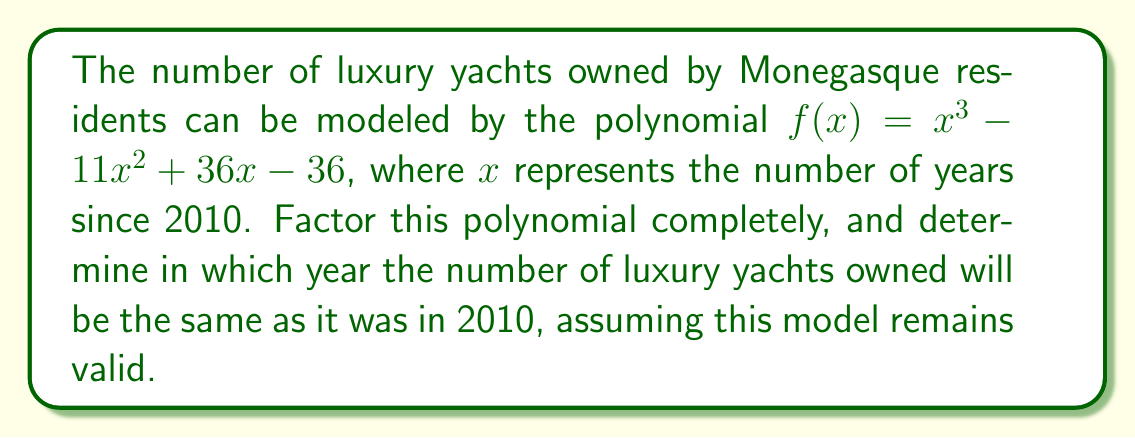Teach me how to tackle this problem. Let's approach this step-by-step:

1) First, we need to factor the polynomial $f(x) = x^3 - 11x^2 + 36x - 36$

2) We can start by checking if there's a common factor. In this case, there isn't.

3) Next, we can try to guess one of the factors. Since the constant term is -36, possible factors are ±1, ±2, ±3, ±4, ±6, ±9, ±12, ±18, ±36. 
   Let's try $(x - 3)$:
   
   $x^3 - 3x^2 = x^2(x - 3)$
   $-11x^2 + 3x^2 = -8x^2$
   $36x - 9x = 27x$
   $-36 + 27 = -9$
   
   It works, so $(x - 3)$ is a factor.

4) We can now divide the original polynomial by $(x - 3)$:

   $\frac{x^3 - 11x^2 + 36x - 36}{x - 3} = x^2 - 8x + 12$

5) The quadratic $x^2 - 8x + 12$ can be factored further:

   $x^2 - 8x + 12 = (x - 6)(x - 2)$

6) Therefore, the complete factorization is:

   $f(x) = (x - 3)(x - 6)(x - 2)$

7) To find when the number of yachts will be the same as in 2010, we need to find when $f(x) = 0$ (besides $x = 0$, which represents 2010).

8) From the factored form, we can see that $f(x) = 0$ when $x = 2, 3,$ or $6$.

9) Since $x$ represents years since 2010, $x = 2$ corresponds to 2012, $x = 3$ to 2013, and $x = 6$ to 2016.

10) We're looking for the future year, so the answer is 2016.
Answer: The polynomial factors as $f(x) = (x - 3)(x - 6)(x - 2)$, and the number of luxury yachts will be the same as in 2010 in the year 2016. 